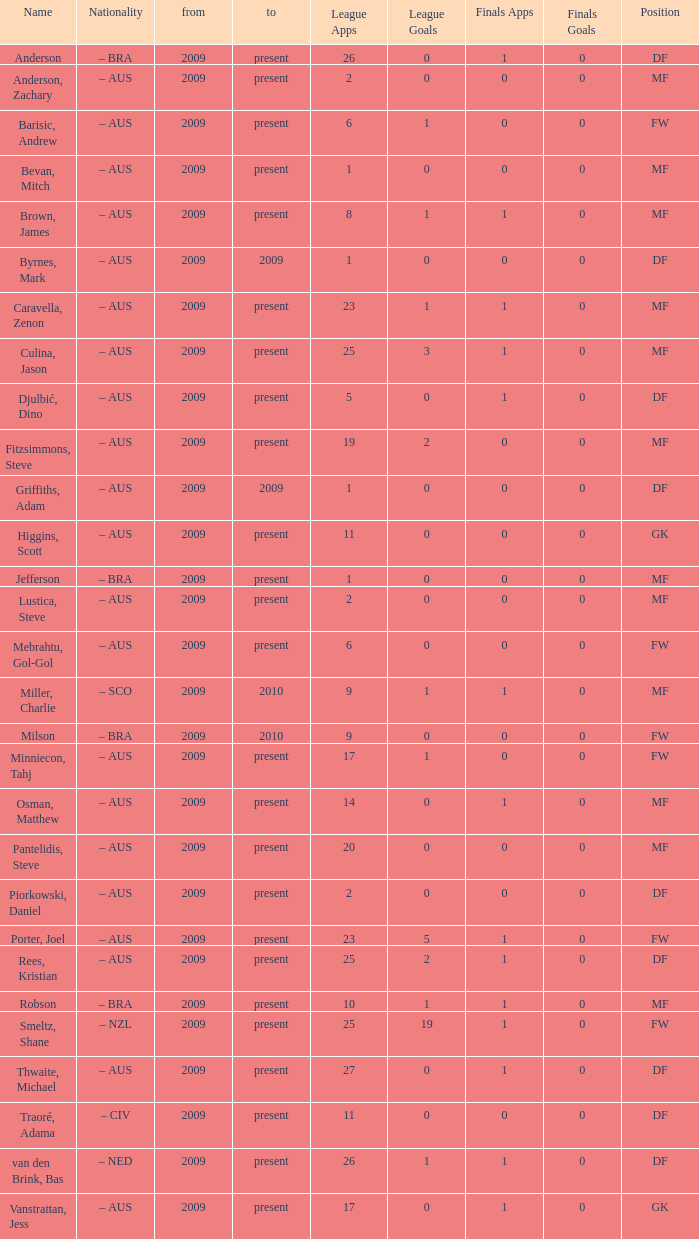Identify the top 19 league applications Present. 